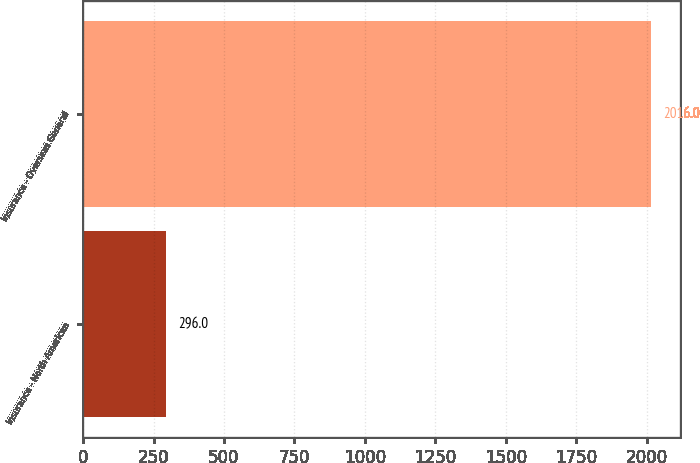<chart> <loc_0><loc_0><loc_500><loc_500><bar_chart><fcel>Insurance - North American<fcel>Insurance - Overseas General<nl><fcel>296<fcel>2016<nl></chart> 